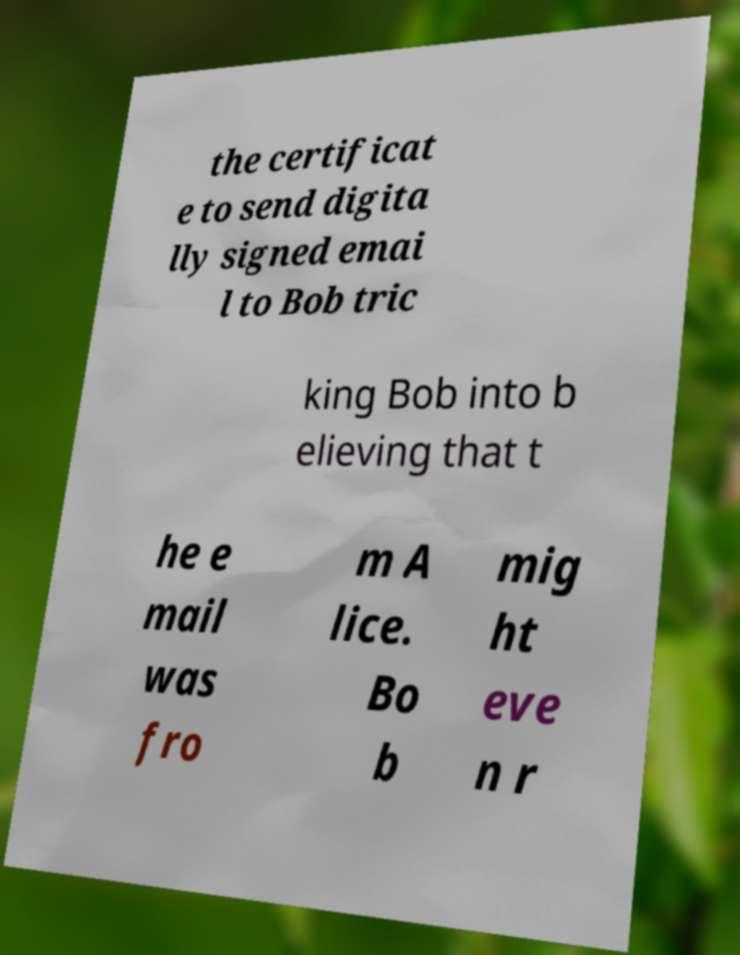For documentation purposes, I need the text within this image transcribed. Could you provide that? the certificat e to send digita lly signed emai l to Bob tric king Bob into b elieving that t he e mail was fro m A lice. Bo b mig ht eve n r 